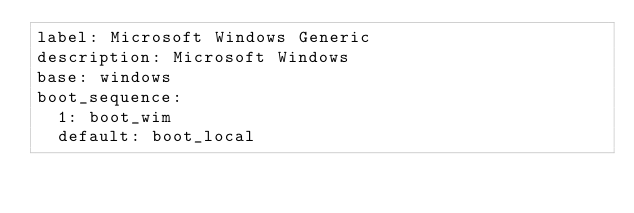Convert code to text. <code><loc_0><loc_0><loc_500><loc_500><_YAML_>label: Microsoft Windows Generic
description: Microsoft Windows
base: windows
boot_sequence:
  1: boot_wim
  default: boot_local
</code> 